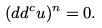Convert formula to latex. <formula><loc_0><loc_0><loc_500><loc_500>( d d ^ { c } u ) ^ { n } = 0 .</formula> 